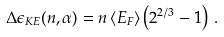<formula> <loc_0><loc_0><loc_500><loc_500>\Delta \epsilon _ { K E } ( n , \alpha ) = n \left < E _ { F } \right > \left ( 2 ^ { 2 / 3 } - 1 \right ) \, .</formula> 